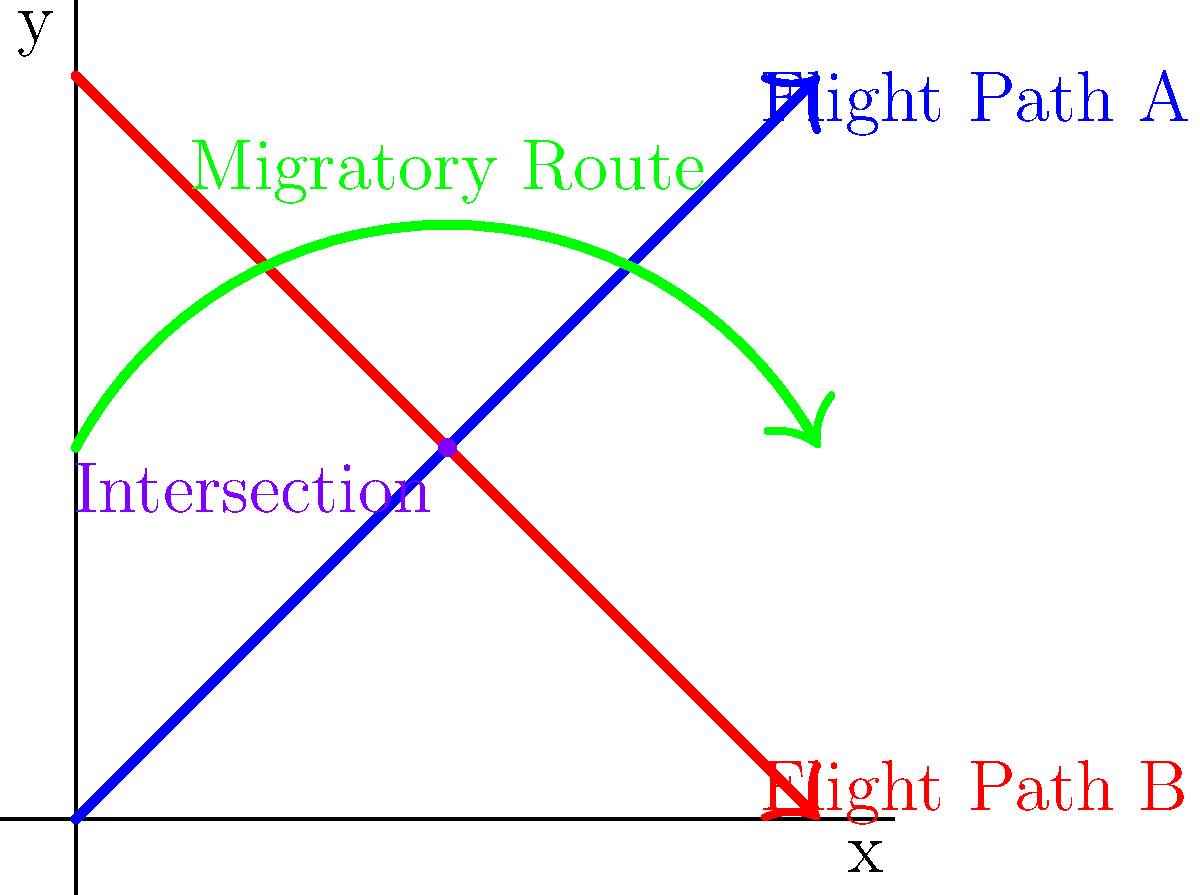The graph shows two flight paths (A and B) and a migratory bird route. Flight Path A is represented by the equation $y = x$, and Flight Path B is represented by $y = -x + 10$. The migratory bird route can be approximated by the quadratic function $y = -0.24x^2 + 2.4x + 2$. At which point do all three paths intersect, potentially causing a significant environmental concern? To find the intersection point, we need to solve the system of equations:

1) $y = x$ (Flight Path A)
2) $y = -x + 10$ (Flight Path B)
3) $y = -0.24x^2 + 2.4x + 2$ (Migratory Route)

Step 1: Find the intersection of Flight Paths A and B
$x = -x + 10$
$2x = 10$
$x = 5$
$y = 5$

Step 2: Verify if this point satisfies the migratory route equation
$y = -0.24(5)^2 + 2.4(5) + 2$
$y = -0.24(25) + 12 + 2$
$y = -6 + 12 + 2$
$y = 8$

Step 3: Since $y ≠ 8$, the point (5, 5) is not the intersection of all three paths.

Step 4: Solve the system of equations algebraically
Substitute $y = x$ into the migratory route equation:
$x = -0.24x^2 + 2.4x + 2$
$0.24x^2 - 1.4x - 2 = 0$

Solve this quadratic equation:
$x = \frac{1.4 \pm \sqrt{1.96 + 1.92}}{0.48}$
$x = \frac{1.4 \pm \sqrt{3.88}}{0.48}$
$x = \frac{1.4 \pm 1.97}{0.48}$

The solution that falls within our graph is:
$x = \frac{1.4 + 1.97}{0.48} ≈ 7.02$

$y = 7.02$

Step 5: Round to the nearest whole number for practical purposes
The intersection point is approximately (7, 7).
Answer: (7, 7) 